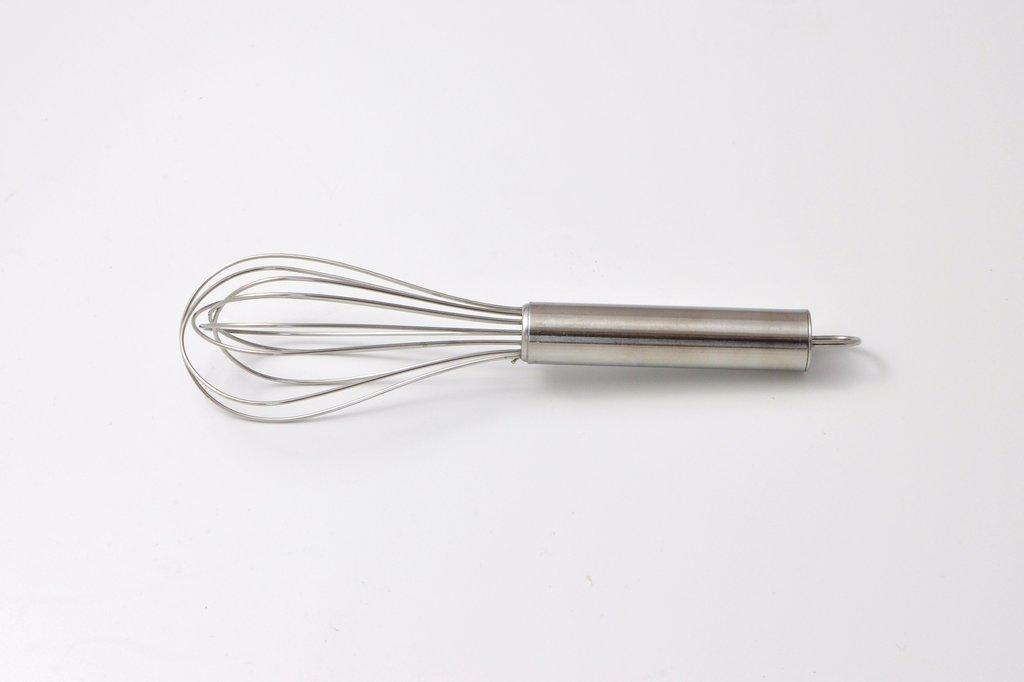What is the main object in the center of the image? There is a whisk in the center of the image. What color is the background of the image? The background of the image is white in color. What type of show is being performed on the stage in the image? There is no stage or show present in the image; it only features a whisk and a white background. How does the whisk aid in the digestion process in the image? The image does not depict any digestion process, and the whisk is not related to digestion. 